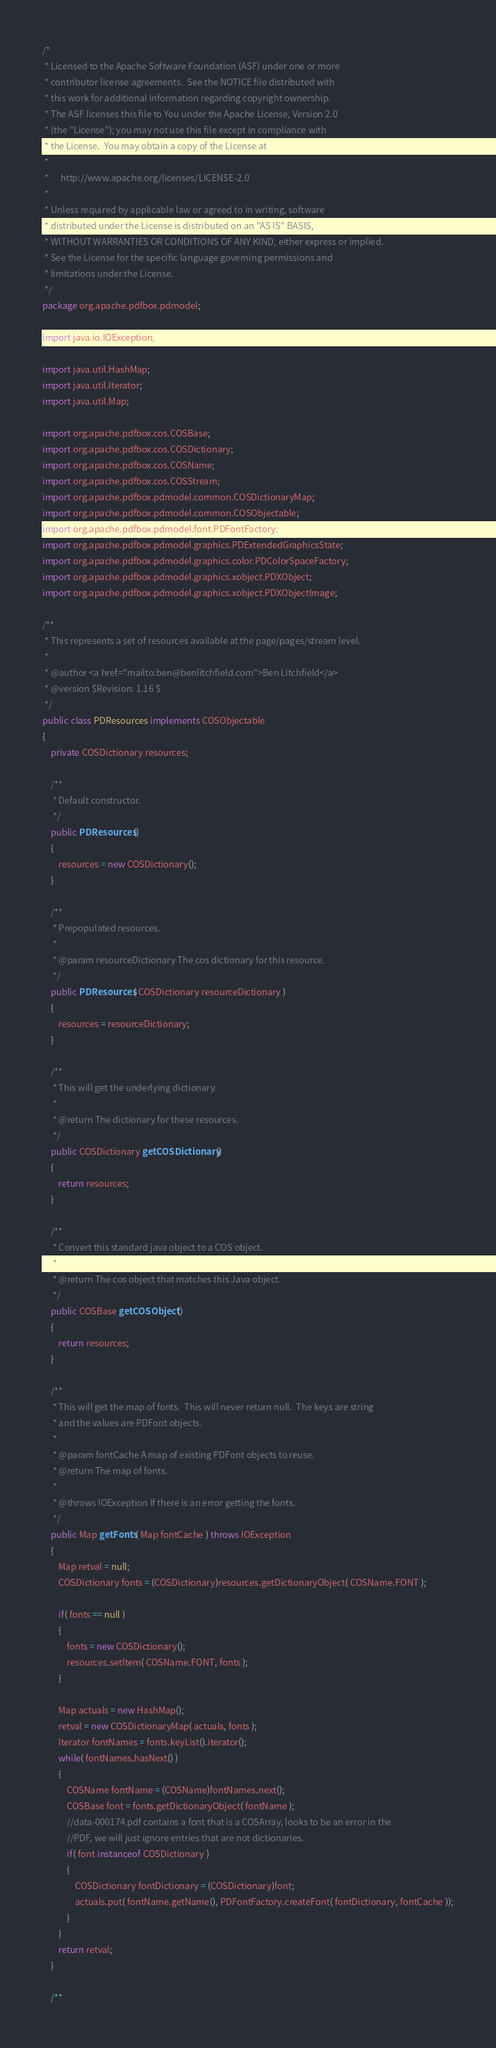Convert code to text. <code><loc_0><loc_0><loc_500><loc_500><_Java_>/*
 * Licensed to the Apache Software Foundation (ASF) under one or more
 * contributor license agreements.  See the NOTICE file distributed with
 * this work for additional information regarding copyright ownership.
 * The ASF licenses this file to You under the Apache License, Version 2.0
 * (the "License"); you may not use this file except in compliance with
 * the License.  You may obtain a copy of the License at
 *
 *      http://www.apache.org/licenses/LICENSE-2.0
 *
 * Unless required by applicable law or agreed to in writing, software
 * distributed under the License is distributed on an "AS IS" BASIS,
 * WITHOUT WARRANTIES OR CONDITIONS OF ANY KIND, either express or implied.
 * See the License for the specific language governing permissions and
 * limitations under the License.
 */
package org.apache.pdfbox.pdmodel;

import java.io.IOException;

import java.util.HashMap;
import java.util.Iterator;
import java.util.Map;

import org.apache.pdfbox.cos.COSBase;
import org.apache.pdfbox.cos.COSDictionary;
import org.apache.pdfbox.cos.COSName;
import org.apache.pdfbox.cos.COSStream;
import org.apache.pdfbox.pdmodel.common.COSDictionaryMap;
import org.apache.pdfbox.pdmodel.common.COSObjectable;
import org.apache.pdfbox.pdmodel.font.PDFontFactory;
import org.apache.pdfbox.pdmodel.graphics.PDExtendedGraphicsState;
import org.apache.pdfbox.pdmodel.graphics.color.PDColorSpaceFactory;
import org.apache.pdfbox.pdmodel.graphics.xobject.PDXObject;
import org.apache.pdfbox.pdmodel.graphics.xobject.PDXObjectImage;

/**
 * This represents a set of resources available at the page/pages/stream level.
 *
 * @author <a href="mailto:ben@benlitchfield.com">Ben Litchfield</a>
 * @version $Revision: 1.16 $
 */
public class PDResources implements COSObjectable
{
    private COSDictionary resources;

    /**
     * Default constructor.
     */
    public PDResources()
    {
        resources = new COSDictionary();
    }

    /**
     * Prepopulated resources.
     *
     * @param resourceDictionary The cos dictionary for this resource.
     */
    public PDResources( COSDictionary resourceDictionary )
    {
        resources = resourceDictionary;
    }

    /**
     * This will get the underlying dictionary.
     *
     * @return The dictionary for these resources.
     */
    public COSDictionary getCOSDictionary()
    {
        return resources;
    }

    /**
     * Convert this standard java object to a COS object.
     *
     * @return The cos object that matches this Java object.
     */
    public COSBase getCOSObject()
    {
        return resources;
    }

    /**
     * This will get the map of fonts.  This will never return null.  The keys are string
     * and the values are PDFont objects.
     *
     * @param fontCache A map of existing PDFont objects to reuse.
     * @return The map of fonts.
     *
     * @throws IOException If there is an error getting the fonts.
     */
    public Map getFonts( Map fontCache ) throws IOException
    {
        Map retval = null;
        COSDictionary fonts = (COSDictionary)resources.getDictionaryObject( COSName.FONT );

        if( fonts == null )
        {
            fonts = new COSDictionary();
            resources.setItem( COSName.FONT, fonts );
        }

        Map actuals = new HashMap();
        retval = new COSDictionaryMap( actuals, fonts );
        Iterator fontNames = fonts.keyList().iterator();
        while( fontNames.hasNext() )
        {
            COSName fontName = (COSName)fontNames.next();
            COSBase font = fonts.getDictionaryObject( fontName );
            //data-000174.pdf contains a font that is a COSArray, looks to be an error in the
            //PDF, we will just ignore entries that are not dictionaries.
            if( font instanceof COSDictionary )
            {
                COSDictionary fontDictionary = (COSDictionary)font;
                actuals.put( fontName.getName(), PDFontFactory.createFont( fontDictionary, fontCache ));
            }
        }
        return retval;
    }

    /**</code> 